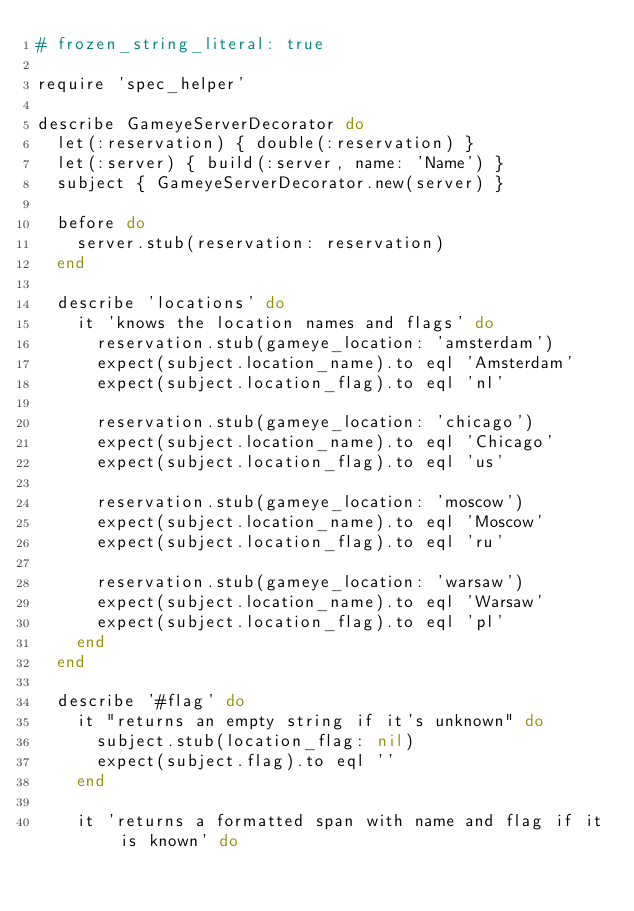Convert code to text. <code><loc_0><loc_0><loc_500><loc_500><_Ruby_># frozen_string_literal: true

require 'spec_helper'

describe GameyeServerDecorator do
  let(:reservation) { double(:reservation) }
  let(:server) { build(:server, name: 'Name') }
  subject { GameyeServerDecorator.new(server) }

  before do
    server.stub(reservation: reservation)
  end

  describe 'locations' do
    it 'knows the location names and flags' do
      reservation.stub(gameye_location: 'amsterdam')
      expect(subject.location_name).to eql 'Amsterdam'
      expect(subject.location_flag).to eql 'nl'

      reservation.stub(gameye_location: 'chicago')
      expect(subject.location_name).to eql 'Chicago'
      expect(subject.location_flag).to eql 'us'

      reservation.stub(gameye_location: 'moscow')
      expect(subject.location_name).to eql 'Moscow'
      expect(subject.location_flag).to eql 'ru'

      reservation.stub(gameye_location: 'warsaw')
      expect(subject.location_name).to eql 'Warsaw'
      expect(subject.location_flag).to eql 'pl'
    end
  end

  describe '#flag' do
    it "returns an empty string if it's unknown" do
      subject.stub(location_flag: nil)
      expect(subject.flag).to eql ''
    end

    it 'returns a formatted span with name and flag if it is known' do</code> 